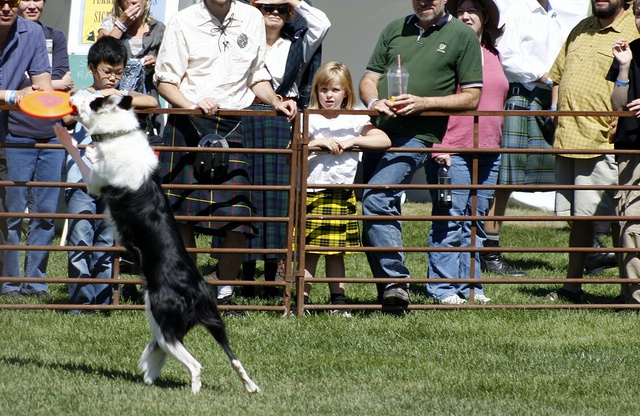Describe the objects in this image and their specific colors. I can see dog in black, white, gray, and darkgray tones, people in black, teal, gray, and darkgreen tones, people in black, khaki, tan, and lightgray tones, people in black, gray, and darkblue tones, and people in black, white, darkgray, and tan tones in this image. 